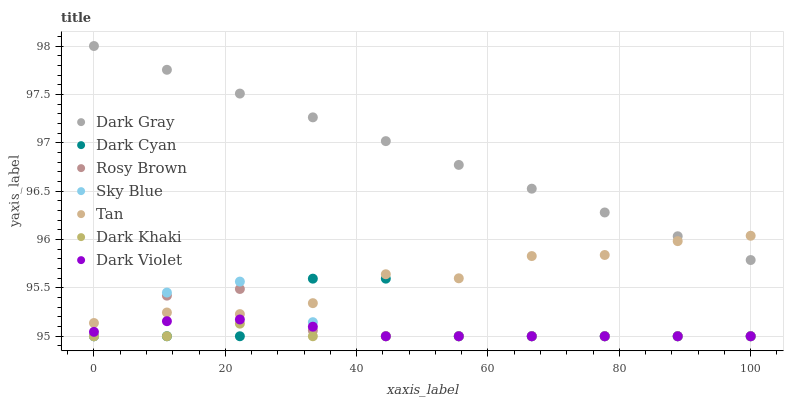Does Dark Khaki have the minimum area under the curve?
Answer yes or no. Yes. Does Dark Gray have the maximum area under the curve?
Answer yes or no. Yes. Does Rosy Brown have the minimum area under the curve?
Answer yes or no. No. Does Rosy Brown have the maximum area under the curve?
Answer yes or no. No. Is Dark Gray the smoothest?
Answer yes or no. Yes. Is Dark Cyan the roughest?
Answer yes or no. Yes. Is Rosy Brown the smoothest?
Answer yes or no. No. Is Rosy Brown the roughest?
Answer yes or no. No. Does Dark Khaki have the lowest value?
Answer yes or no. Yes. Does Dark Gray have the lowest value?
Answer yes or no. No. Does Dark Gray have the highest value?
Answer yes or no. Yes. Does Rosy Brown have the highest value?
Answer yes or no. No. Is Dark Violet less than Tan?
Answer yes or no. Yes. Is Tan greater than Dark Khaki?
Answer yes or no. Yes. Does Rosy Brown intersect Tan?
Answer yes or no. Yes. Is Rosy Brown less than Tan?
Answer yes or no. No. Is Rosy Brown greater than Tan?
Answer yes or no. No. Does Dark Violet intersect Tan?
Answer yes or no. No. 